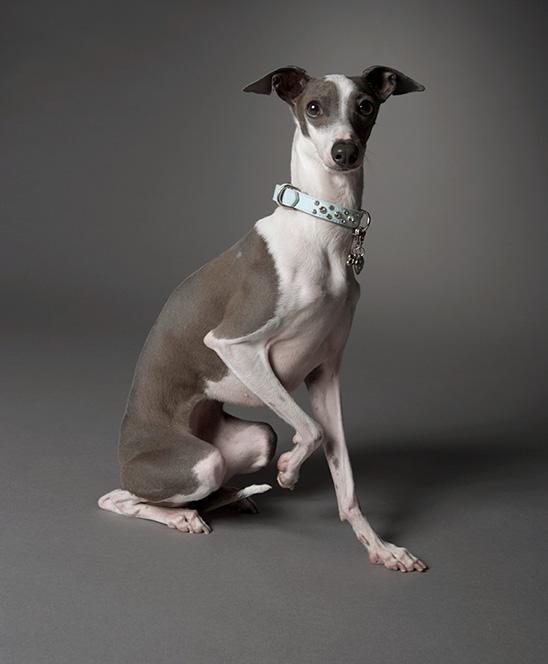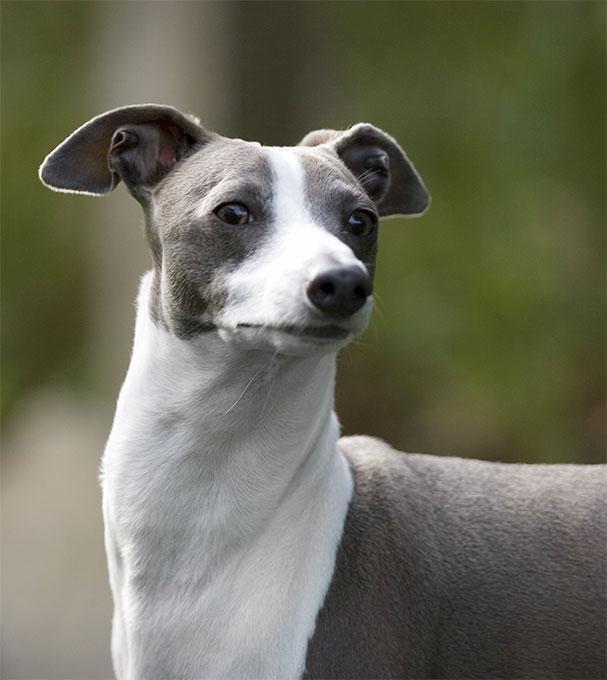The first image is the image on the left, the second image is the image on the right. Analyze the images presented: Is the assertion "One of the images contains a dog without visible legs." valid? Answer yes or no. Yes. 